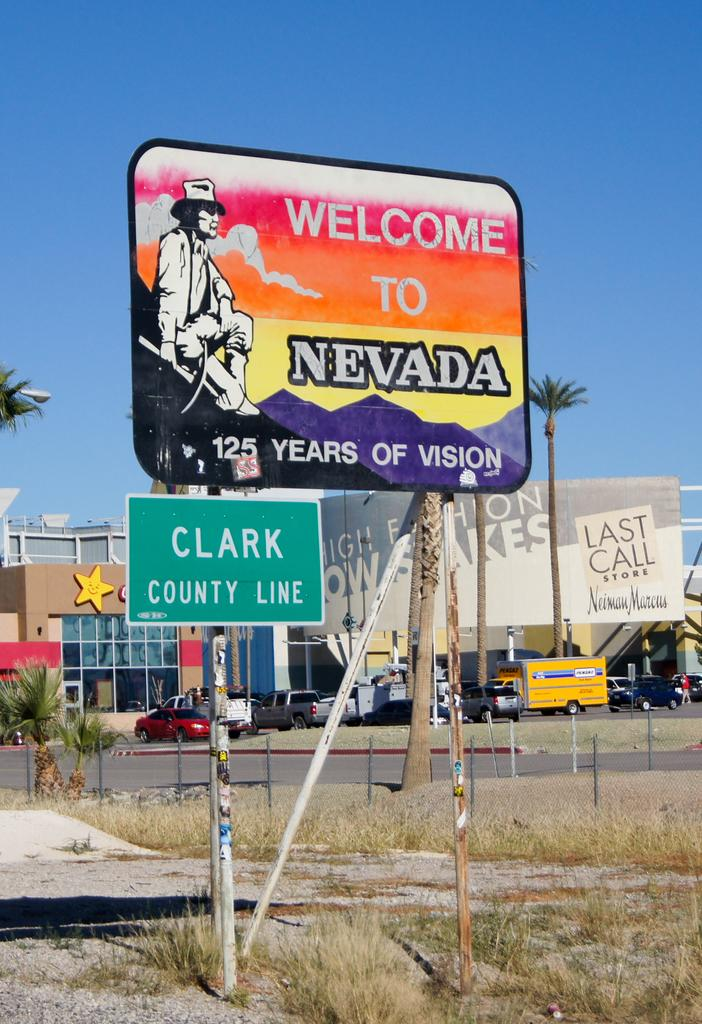Provide a one-sentence caption for the provided image. The Clark County Line is on the Nevada border. 